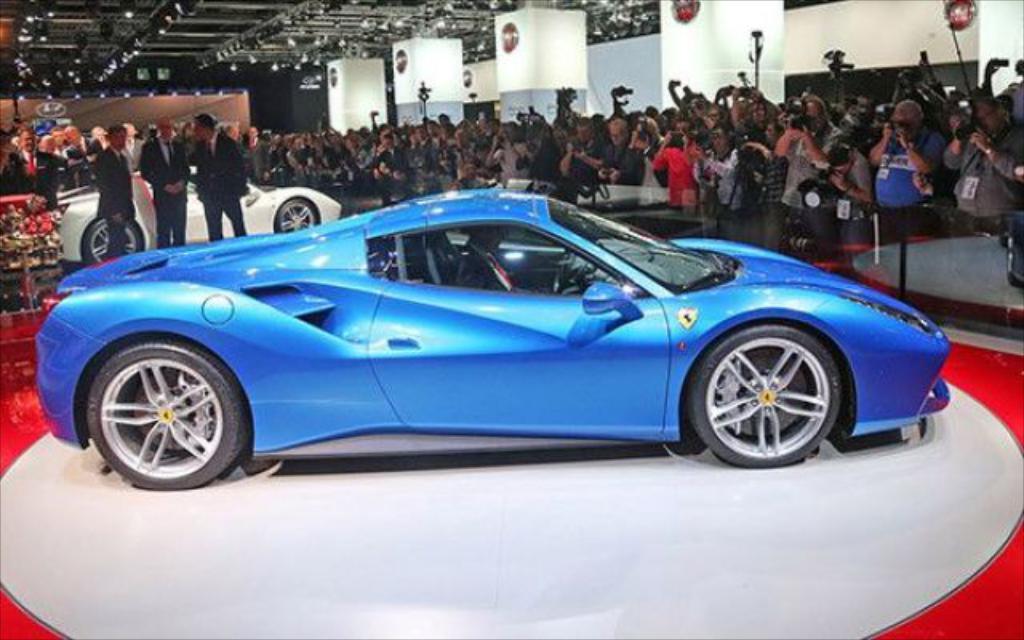Please provide a concise description of this image. In the center of the image we can see two cars. In the background of the image we can see a group of people are standing and some of them are holding cameras. At the top of the image we can see pillars, wall, boards. At the top of the image we can see lights and roof. At the bottom of the image we can see the floor. 